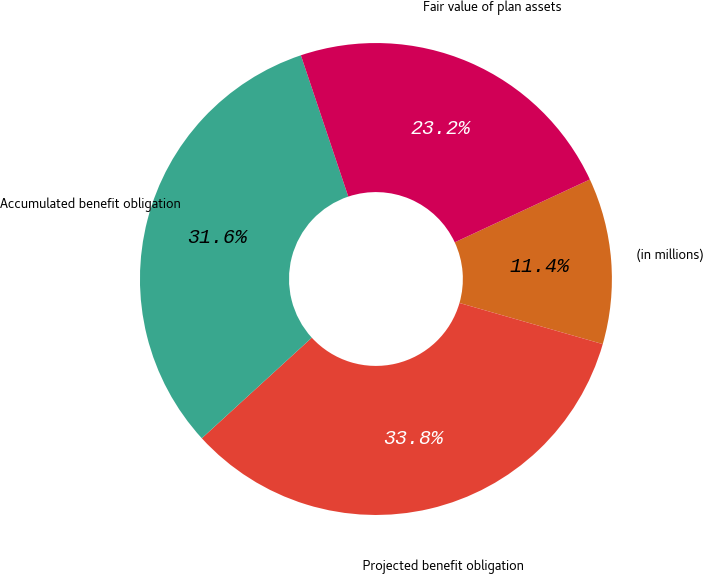Convert chart. <chart><loc_0><loc_0><loc_500><loc_500><pie_chart><fcel>(in millions)<fcel>Projected benefit obligation<fcel>Accumulated benefit obligation<fcel>Fair value of plan assets<nl><fcel>11.38%<fcel>33.76%<fcel>31.64%<fcel>23.22%<nl></chart> 